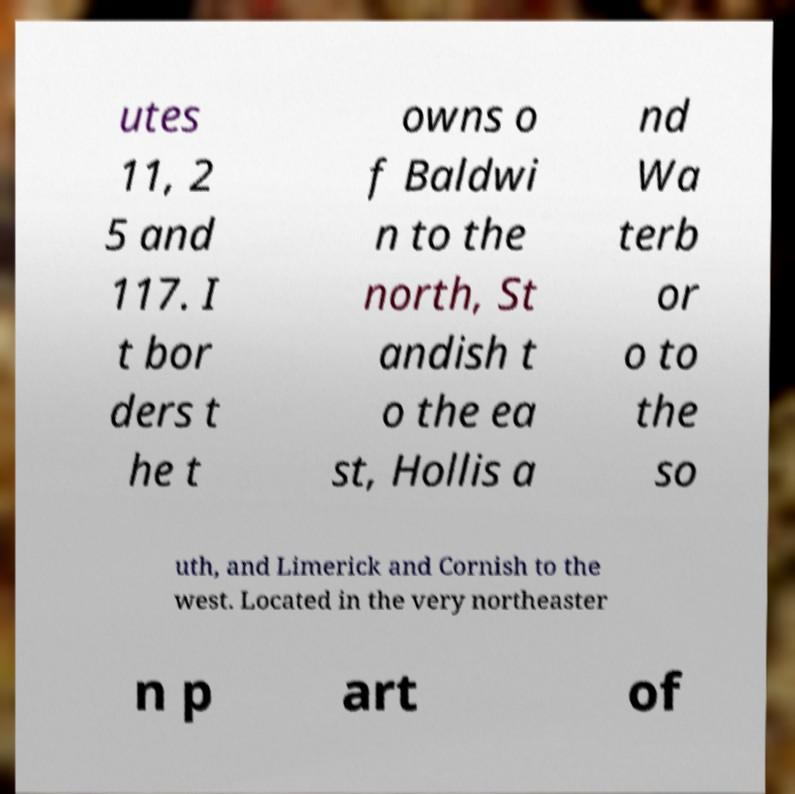Can you accurately transcribe the text from the provided image for me? utes 11, 2 5 and 117. I t bor ders t he t owns o f Baldwi n to the north, St andish t o the ea st, Hollis a nd Wa terb or o to the so uth, and Limerick and Cornish to the west. Located in the very northeaster n p art of 